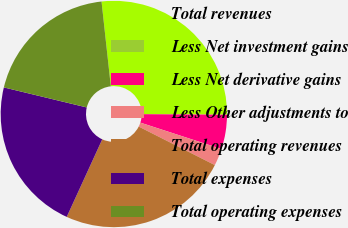Convert chart to OTSL. <chart><loc_0><loc_0><loc_500><loc_500><pie_chart><fcel>Total revenues<fcel>Less Net investment gains<fcel>Less Net derivative gains<fcel>Less Other adjustments to<fcel>Total operating revenues<fcel>Total expenses<fcel>Total operating expenses<nl><fcel>26.83%<fcel>0.01%<fcel>4.9%<fcel>2.45%<fcel>24.38%<fcel>21.94%<fcel>19.49%<nl></chart> 